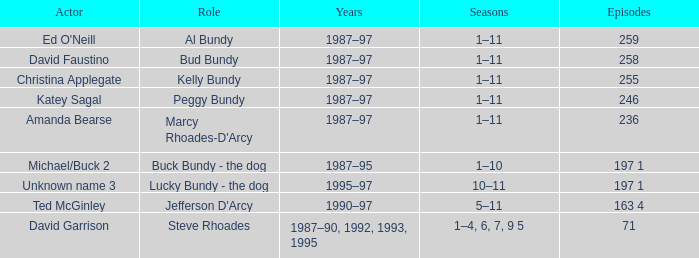What is the count of episodes featuring the actor david faustino? 258.0. 